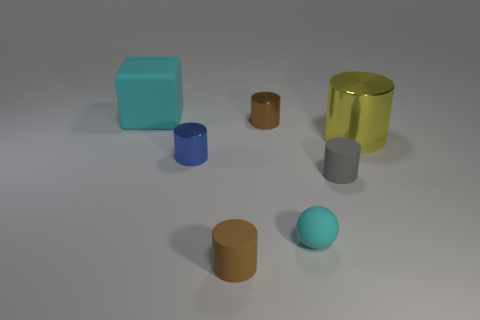Subtract 1 cylinders. How many cylinders are left? 4 Subtract all yellow cylinders. How many cylinders are left? 4 Subtract all gray matte cylinders. How many cylinders are left? 4 Subtract all cyan cylinders. Subtract all cyan balls. How many cylinders are left? 5 Add 1 metallic cylinders. How many objects exist? 8 Subtract all cubes. How many objects are left? 6 Subtract all large cyan blocks. Subtract all small blue objects. How many objects are left? 5 Add 7 small blue cylinders. How many small blue cylinders are left? 8 Add 5 gray metallic cubes. How many gray metallic cubes exist? 5 Subtract 0 brown balls. How many objects are left? 7 